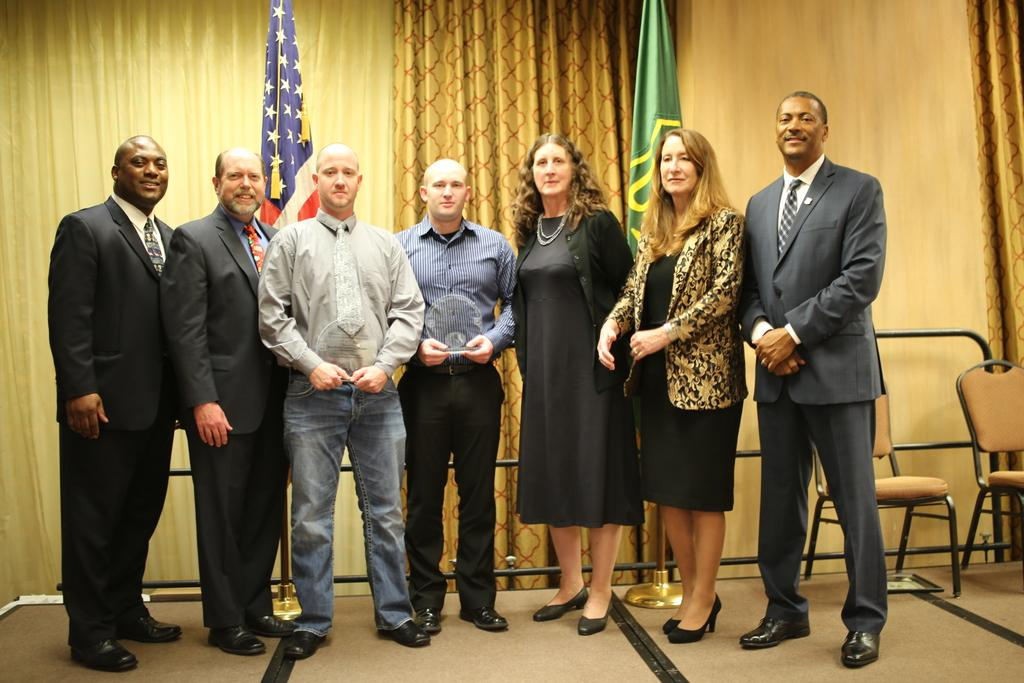What is the main subject of the image? The main subject of the image is people standing. What objects are present in the image that the people might use? There are chairs, flags, stands, and rods in the image. What can be seen in the background of the image? There are curtains visible in the background of the image. What type of pest can be seen crawling on the flag in the image? There is no pest visible on the flag in the image. What type of apparel is the person wearing in the image? The provided facts do not mention any specific apparel worn by the people in the image. 